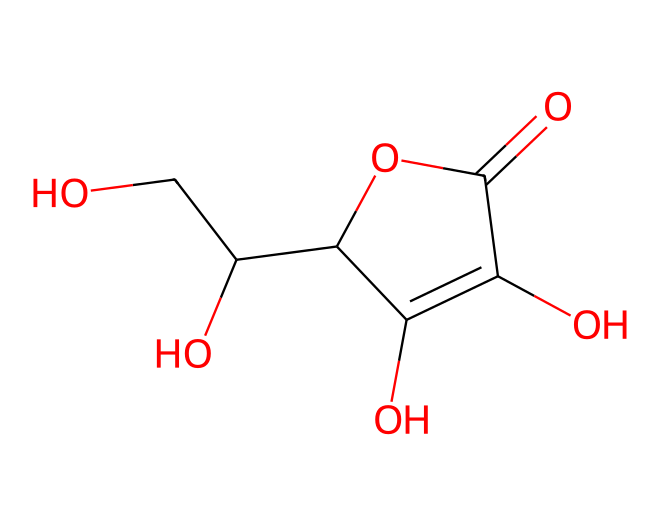what is the molecular formula of ascorbic acid? By analyzing the structure and counting each type of atom present in the SMILES representation, we find there are six carbons, eight hydrogens, and six oxygens. Therefore, the molecular formula is C6H8O6.
Answer: C6H8O6 how many hydroxyl groups are present? Looking at the structure, there are four -OH groups (indicated by the oxygen atoms connected to hydrogen atoms). Thus, ascorbic acid contains four hydroxyl groups.
Answer: four is ascorbic acid a solid at room temperature? Ascorbic acid is classified as a solid at room temperature. This is because it possesses a crystalline structure, which is typical for many organic compounds with such features.
Answer: yes what type of functional groups are present in ascorbic acid? The molecule contains hydroxyl (alcohol) and carboxylic acid functional groups. Hydroxyl groups are indicated by -OH and the carboxylic acid group is represented by the -COOH part of the structure.
Answer: hydroxyl and carboxylic acid how many double bonds are there in the structure? Examining the structure, you can see that there are two double bonds present: one between carbon and carbon and another in the carboxylic acid group (between carbon and oxygen). Thus, the total number of double bonds is two.
Answer: two what is the configuration of ascorbic acid around the stereocenters? Upon evaluation, ascorbic acid has two stereocenters as indicated by asymmetric carbons in the structure. These stereocenters are crucial as they lead to the molecule's specific three-dimensional orientation, which affects its biologic activity.
Answer: two stereocenters what is the primary functional role of ascorbic acid in the human body? The primary role of ascorbic acid is as an antioxidant. Its structure allows it to donate electrons easily, neutralizing free radicals and preventing cellular damage.
Answer: antioxidant 